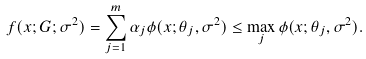Convert formula to latex. <formula><loc_0><loc_0><loc_500><loc_500>f ( x ; G ; \sigma ^ { 2 } ) = \sum _ { j = 1 } ^ { m } \alpha _ { j } \phi ( x ; \theta _ { j } , \sigma ^ { 2 } ) \leq \max _ { j } \phi ( x ; \theta _ { j } , \sigma ^ { 2 } ) .</formula> 